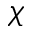Convert formula to latex. <formula><loc_0><loc_0><loc_500><loc_500>\chi</formula> 